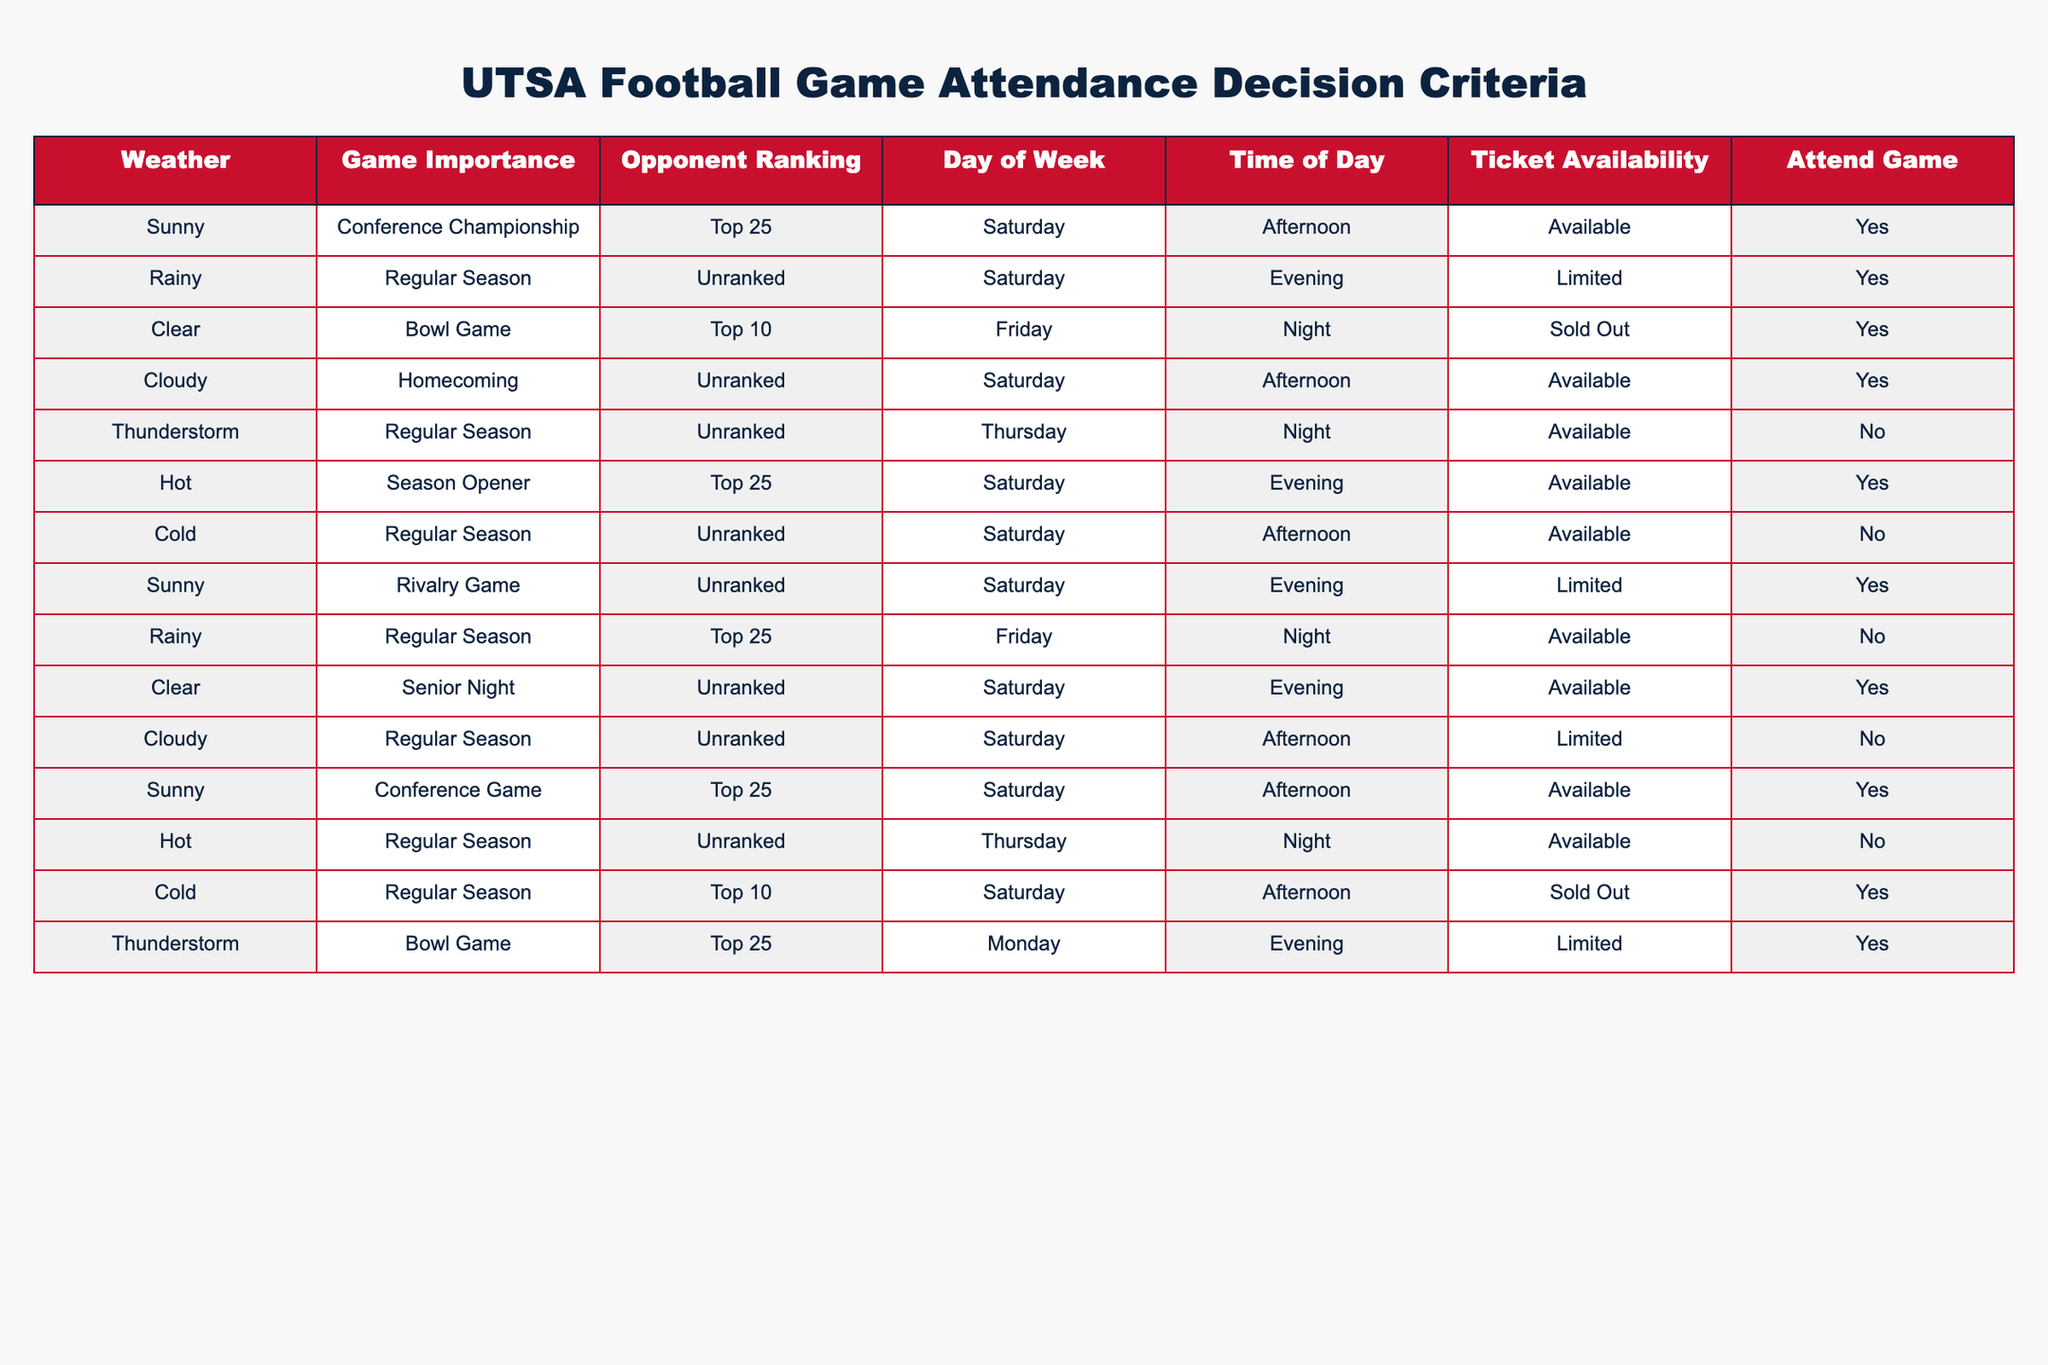What is the attendance decision for a game on a rainy day against a ranked opponent? The table shows two entries for rainy days: one for a regular season game against an unranked opponent with attendance Yes, and one for a regular season game against a top 25 opponent with attendance No. Since none fit both conditions of a rainy day against a ranked opponent together, the answer is not directly found in the table.
Answer: No decision available How many games have attendance marked as Yes? By inspecting the table, we can count the rows where the Attend Game column is Yes. Those rows are for Conference Championship, Regular Season (unranked), Bowl Game, Homecoming, Season Opener, Rivalry Game, Senior Night, Conference Game, Cold game (Top 10), and Thunderstorm (Bowl Game). This gives a total count of 8 games.
Answer: 8 Is there a game on a Thursday with available tickets? There are two games on Thursdays: one with limited tickets during a thunderstorm and one that occurs in a regular season with available tickets. Therefore, there is no instance of Thursday game with available tickets in the table.
Answer: No What is the maximum opponent ranking for games with attendance marked as Yes? We will need to filter the entries where Attend Game is Yes and then look at the Opponent Ranking. The games with Yes attendance against ranked opponents are Conference Championship (Top 25), Bowl Game (Top 10), Season Opener (Top 25), and Cold (Top 10). The highest ranking among these is Top 10.
Answer: Top 10 Does every game in a sunny weather result in an attendance? Reviewing rows for sunny games, we find: Conference Championship, Season Opener, and Rivalry Game all have attendance marked as Yes. Therefore, while most sunny games are attended, there is no absolute guarantee since attendance is not universal.
Answer: No 